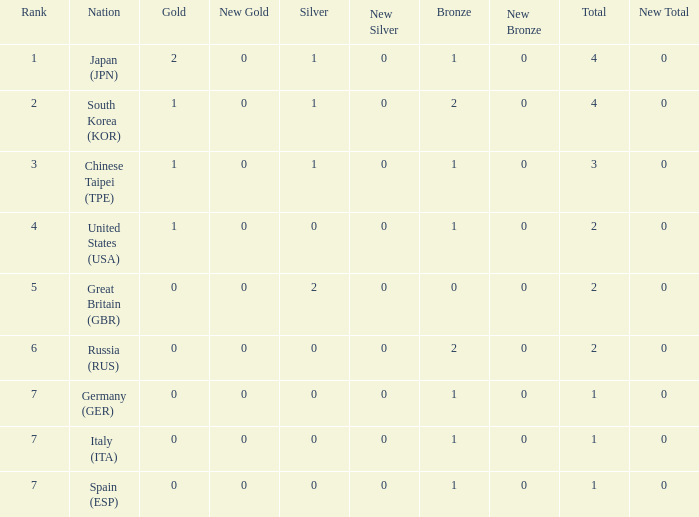What is the smallest number of gold of a country of rank 6, with 2 bronzes? None. 